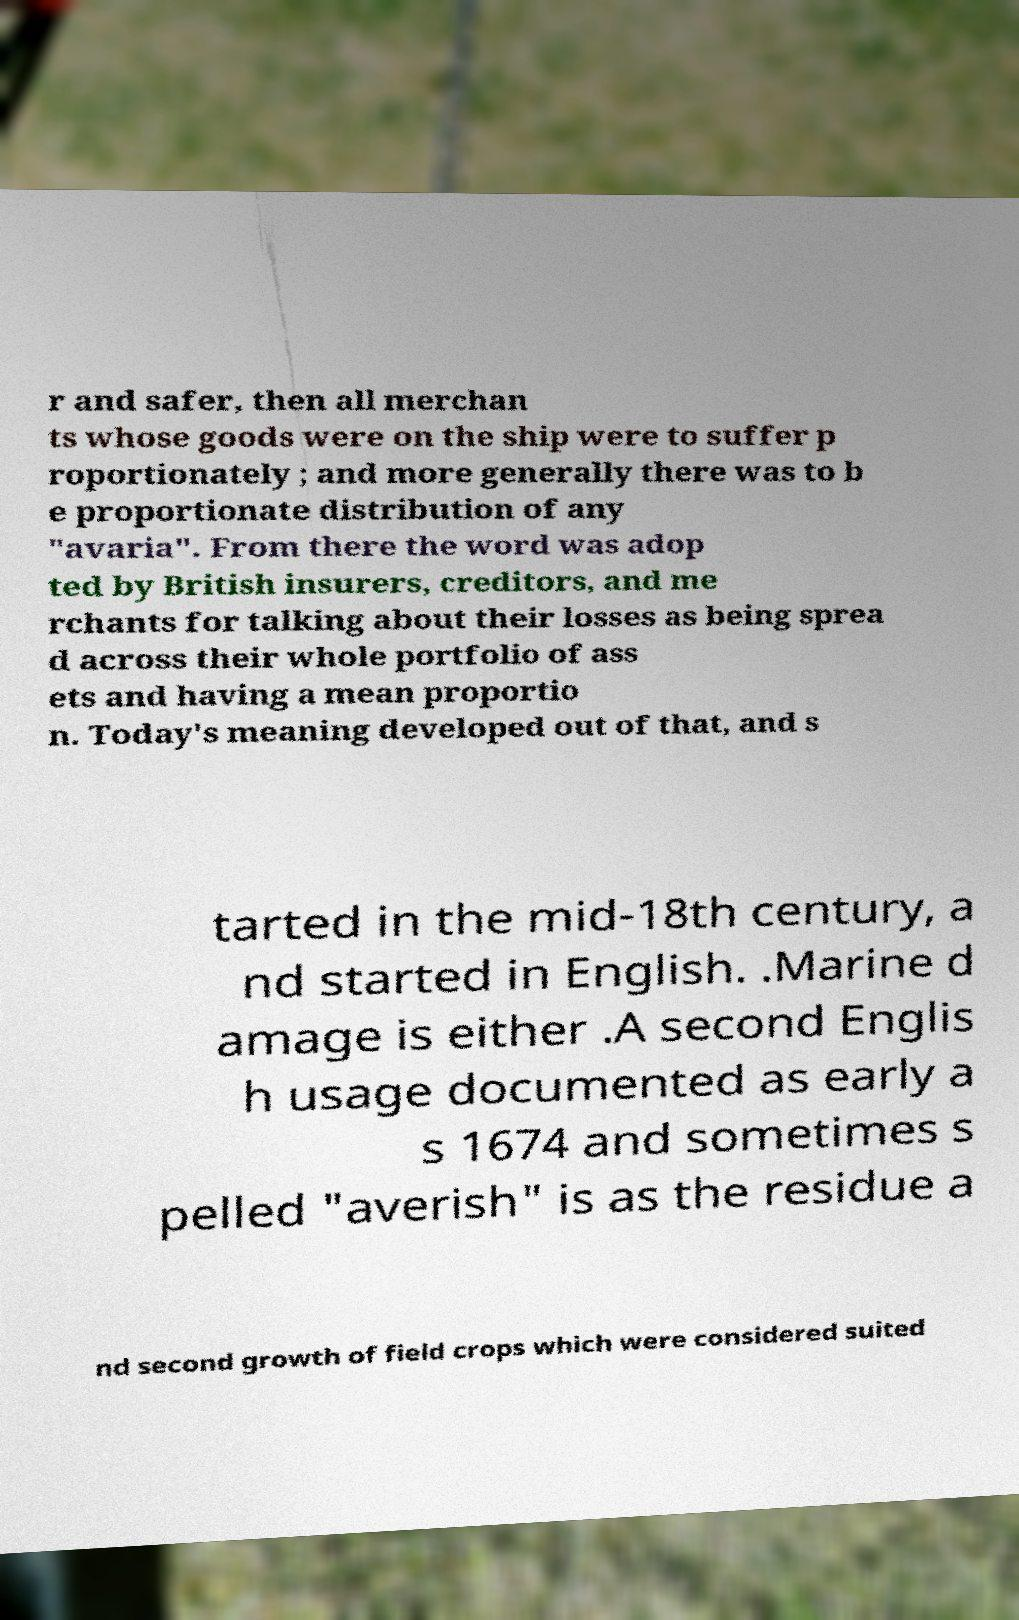Please read and relay the text visible in this image. What does it say? r and safer, then all merchan ts whose goods were on the ship were to suffer p roportionately ; and more generally there was to b e proportionate distribution of any "avaria". From there the word was adop ted by British insurers, creditors, and me rchants for talking about their losses as being sprea d across their whole portfolio of ass ets and having a mean proportio n. Today's meaning developed out of that, and s tarted in the mid-18th century, a nd started in English. .Marine d amage is either .A second Englis h usage documented as early a s 1674 and sometimes s pelled "averish" is as the residue a nd second growth of field crops which were considered suited 